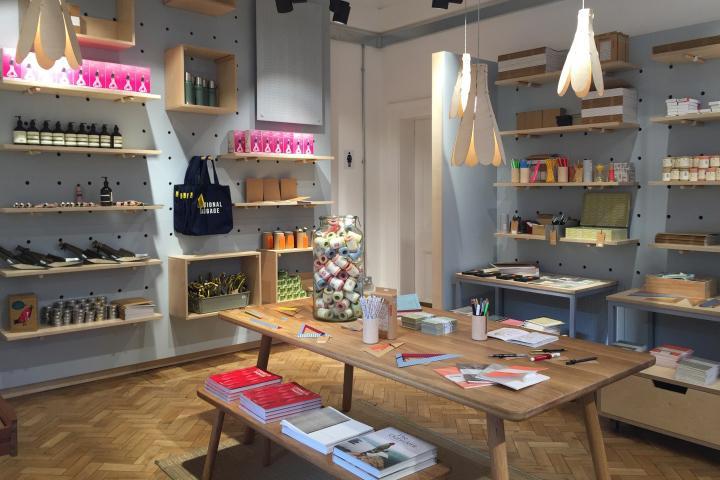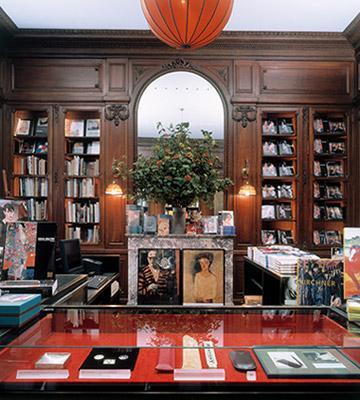The first image is the image on the left, the second image is the image on the right. Evaluate the accuracy of this statement regarding the images: "In at least one image there are two bright orange ball lamps that are on hanging from the ceiling  of either side of an archway". Is it true? Answer yes or no. No. 